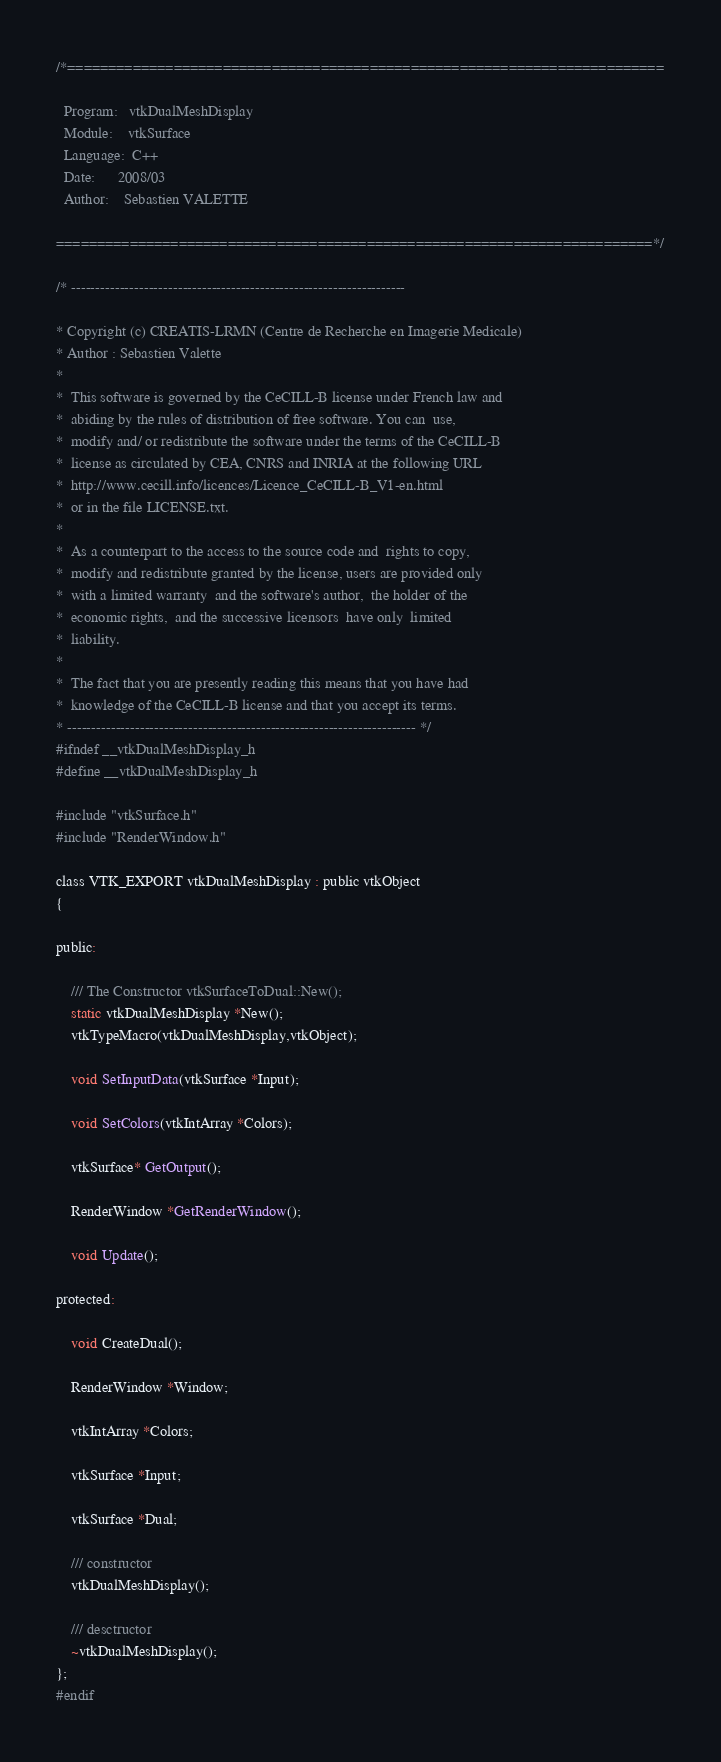Convert code to text. <code><loc_0><loc_0><loc_500><loc_500><_C_>/*=========================================================================

  Program:   vtkDualMeshDisplay
  Module:    vtkSurface
  Language:  C++
  Date:      2008/03
  Author:    Sebastien VALETTE

=========================================================================*/

/* ---------------------------------------------------------------------

* Copyright (c) CREATIS-LRMN (Centre de Recherche en Imagerie Medicale)
* Author : Sebastien Valette
*
*  This software is governed by the CeCILL-B license under French law and 
*  abiding by the rules of distribution of free software. You can  use, 
*  modify and/ or redistribute the software under the terms of the CeCILL-B 
*  license as circulated by CEA, CNRS and INRIA at the following URL 
*  http://www.cecill.info/licences/Licence_CeCILL-B_V1-en.html 
*  or in the file LICENSE.txt.
*
*  As a counterpart to the access to the source code and  rights to copy,
*  modify and redistribute granted by the license, users are provided only
*  with a limited warranty  and the software's author,  the holder of the
*  economic rights,  and the successive licensors  have only  limited
*  liability. 
*
*  The fact that you are presently reading this means that you have had
*  knowledge of the CeCILL-B license and that you accept its terms.
* ------------------------------------------------------------------------ */  
#ifndef __vtkDualMeshDisplay_h
#define __vtkDualMeshDisplay_h

#include "vtkSurface.h"
#include "RenderWindow.h"

class VTK_EXPORT vtkDualMeshDisplay : public vtkObject
{

public:

	/// The Constructor vtkSurfaceToDual::New();
	static vtkDualMeshDisplay *New();
	vtkTypeMacro(vtkDualMeshDisplay,vtkObject);

	void SetInputData(vtkSurface *Input);

	void SetColors(vtkIntArray *Colors);

	vtkSurface* GetOutput();

	RenderWindow *GetRenderWindow();
	
	void Update();

protected:

	void CreateDual();

	RenderWindow *Window;

	vtkIntArray *Colors;
	
	vtkSurface *Input;

	vtkSurface *Dual;

	/// constructor
	vtkDualMeshDisplay();

	/// desctructor
	~vtkDualMeshDisplay();
};
#endif
</code> 